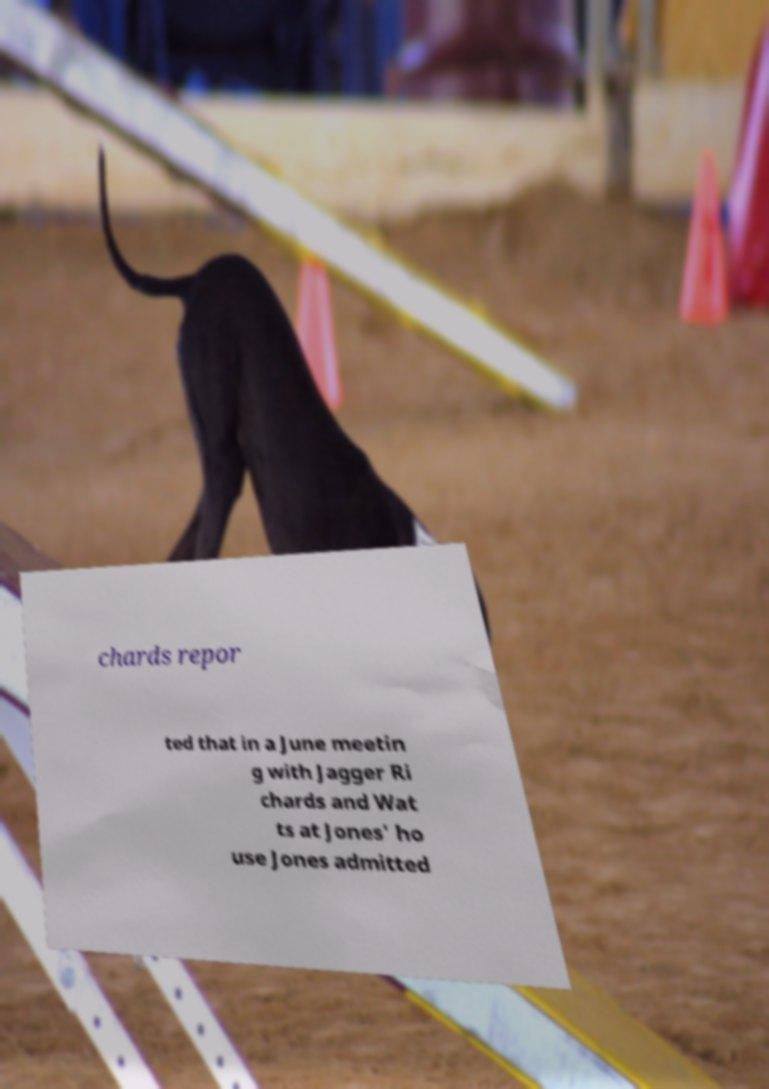Can you accurately transcribe the text from the provided image for me? chards repor ted that in a June meetin g with Jagger Ri chards and Wat ts at Jones' ho use Jones admitted 